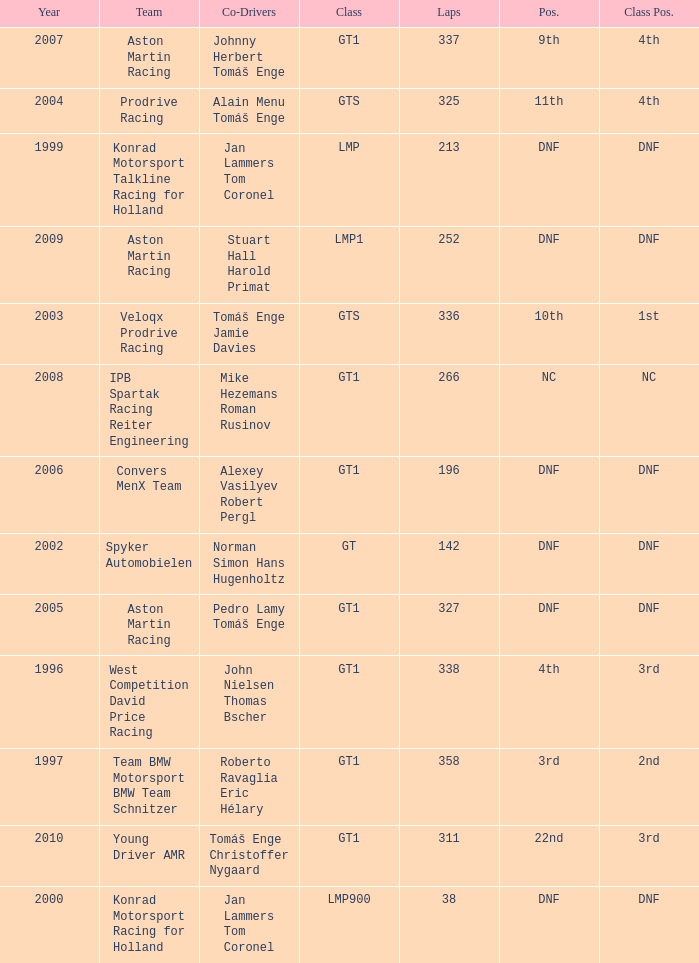What was the position in 1997? 3rd. 